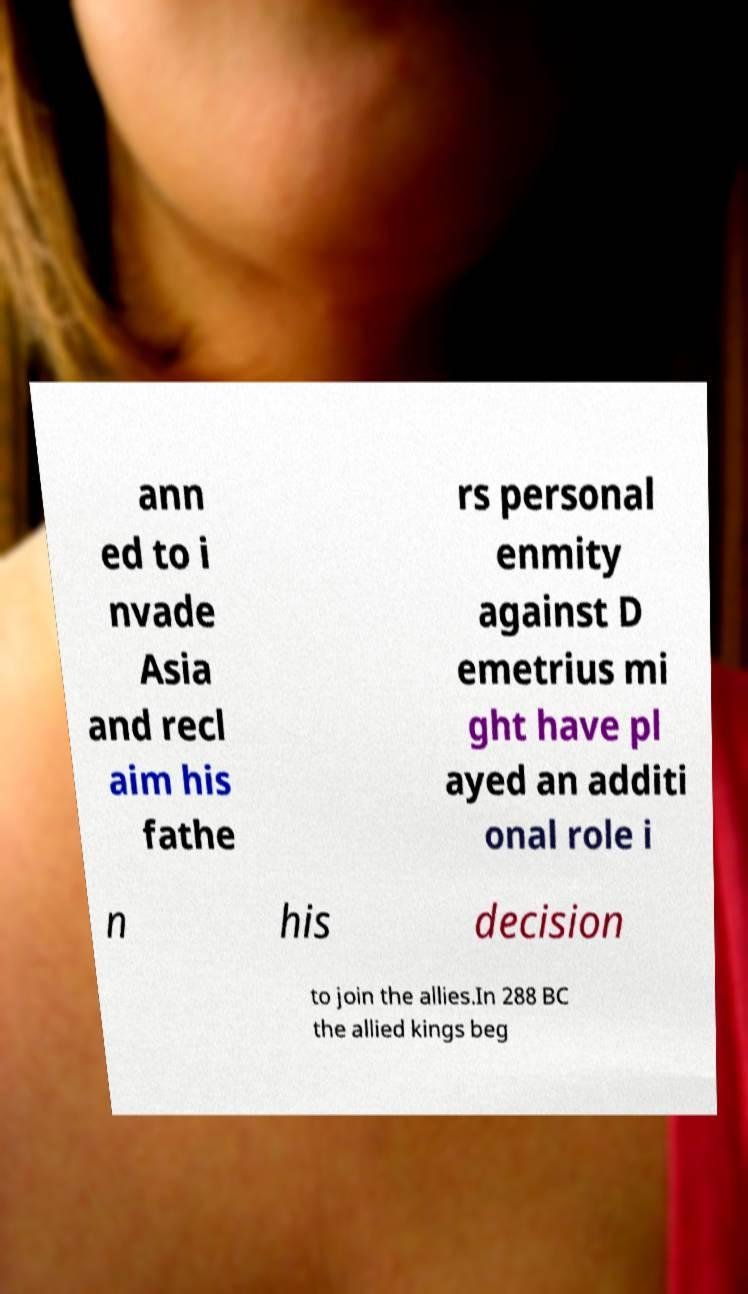Please identify and transcribe the text found in this image. ann ed to i nvade Asia and recl aim his fathe rs personal enmity against D emetrius mi ght have pl ayed an additi onal role i n his decision to join the allies.In 288 BC the allied kings beg 